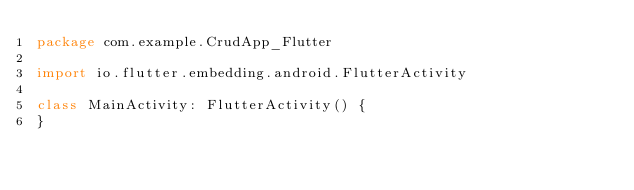Convert code to text. <code><loc_0><loc_0><loc_500><loc_500><_Kotlin_>package com.example.CrudApp_Flutter

import io.flutter.embedding.android.FlutterActivity

class MainActivity: FlutterActivity() {
}
</code> 